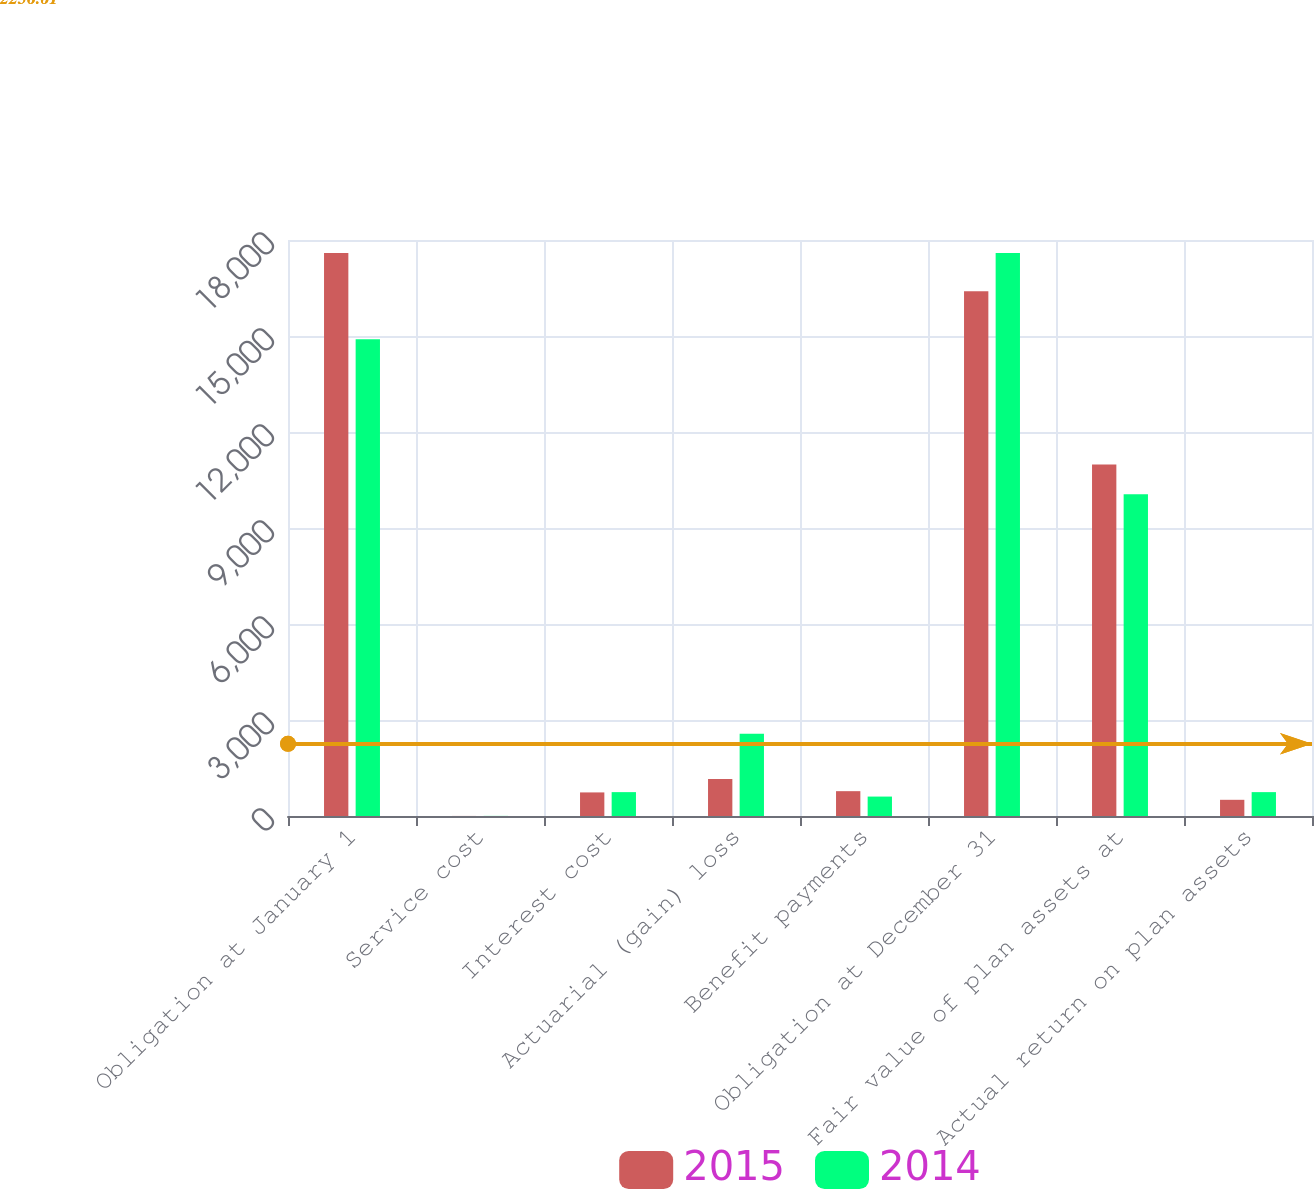<chart> <loc_0><loc_0><loc_500><loc_500><stacked_bar_chart><ecel><fcel>Obligation at January 1<fcel>Service cost<fcel>Interest cost<fcel>Actuarial (gain) loss<fcel>Benefit payments<fcel>Obligation at December 31<fcel>Fair value of plan assets at<fcel>Actual return on plan assets<nl><fcel>2015<fcel>17594<fcel>2<fcel>737<fcel>1159<fcel>776<fcel>16395<fcel>10986<fcel>506<nl><fcel>2014<fcel>14899<fcel>3<fcel>746<fcel>2573<fcel>607<fcel>17594<fcel>10057<fcel>746<nl></chart> 